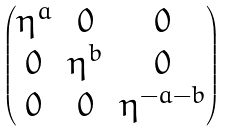Convert formula to latex. <formula><loc_0><loc_0><loc_500><loc_500>\begin{pmatrix} \eta ^ { a } & 0 & 0 \\ 0 & \eta ^ { b } & 0 \\ 0 & 0 & \eta ^ { - a - b } \\ \end{pmatrix}</formula> 